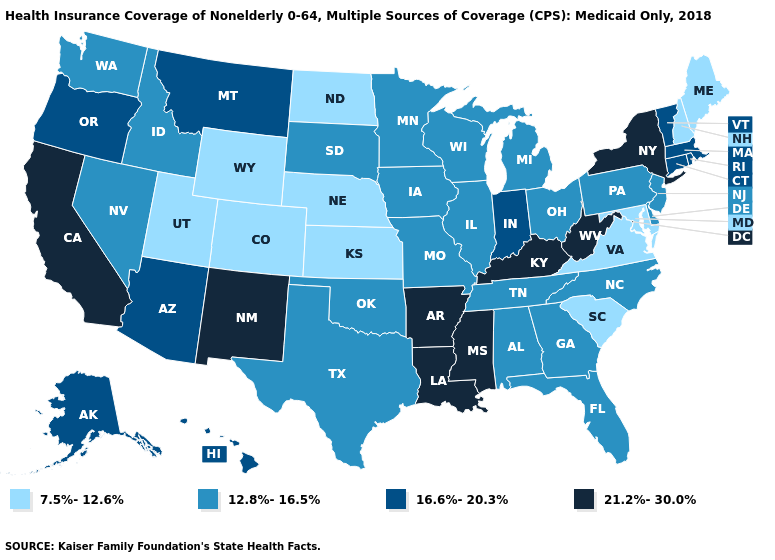What is the highest value in the USA?
Give a very brief answer. 21.2%-30.0%. Does Colorado have a lower value than Illinois?
Be succinct. Yes. Name the states that have a value in the range 12.8%-16.5%?
Concise answer only. Alabama, Delaware, Florida, Georgia, Idaho, Illinois, Iowa, Michigan, Minnesota, Missouri, Nevada, New Jersey, North Carolina, Ohio, Oklahoma, Pennsylvania, South Dakota, Tennessee, Texas, Washington, Wisconsin. Does Delaware have the same value as Oklahoma?
Write a very short answer. Yes. Name the states that have a value in the range 12.8%-16.5%?
Give a very brief answer. Alabama, Delaware, Florida, Georgia, Idaho, Illinois, Iowa, Michigan, Minnesota, Missouri, Nevada, New Jersey, North Carolina, Ohio, Oklahoma, Pennsylvania, South Dakota, Tennessee, Texas, Washington, Wisconsin. Name the states that have a value in the range 21.2%-30.0%?
Concise answer only. Arkansas, California, Kentucky, Louisiana, Mississippi, New Mexico, New York, West Virginia. Is the legend a continuous bar?
Give a very brief answer. No. Does the map have missing data?
Answer briefly. No. Name the states that have a value in the range 16.6%-20.3%?
Quick response, please. Alaska, Arizona, Connecticut, Hawaii, Indiana, Massachusetts, Montana, Oregon, Rhode Island, Vermont. What is the value of Kentucky?
Quick response, please. 21.2%-30.0%. Does Louisiana have a lower value than Virginia?
Give a very brief answer. No. How many symbols are there in the legend?
Short answer required. 4. Does Vermont have the highest value in the Northeast?
Give a very brief answer. No. Which states have the lowest value in the USA?
Keep it brief. Colorado, Kansas, Maine, Maryland, Nebraska, New Hampshire, North Dakota, South Carolina, Utah, Virginia, Wyoming. Among the states that border Delaware , does Maryland have the highest value?
Quick response, please. No. 